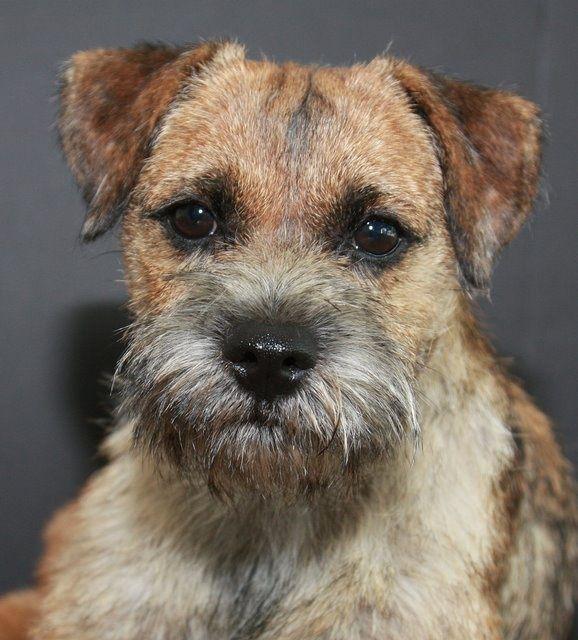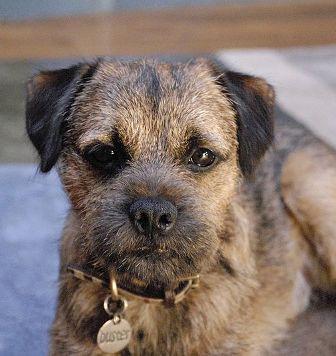The first image is the image on the left, the second image is the image on the right. Considering the images on both sides, is "One dog is wearing a collar with a round tag clearly visible." valid? Answer yes or no. Yes. 